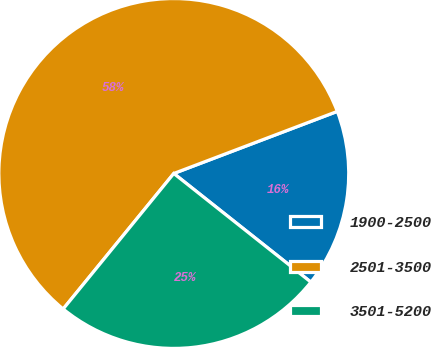Convert chart. <chart><loc_0><loc_0><loc_500><loc_500><pie_chart><fcel>1900-2500<fcel>2501-3500<fcel>3501-5200<nl><fcel>16.44%<fcel>58.33%<fcel>25.23%<nl></chart> 